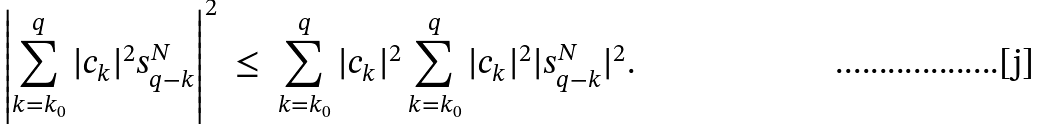<formula> <loc_0><loc_0><loc_500><loc_500>\left | \sum _ { k = k _ { 0 } } ^ { q } | c _ { k } | ^ { 2 } s ^ { N } _ { q - k } \right | ^ { 2 } \ \leq \ \sum _ { k = k _ { 0 } } ^ { q } | c _ { k } | ^ { 2 } \sum _ { k = k _ { 0 } } ^ { q } | c _ { k } | ^ { 2 } | s ^ { N } _ { q - k } | ^ { 2 } .</formula> 